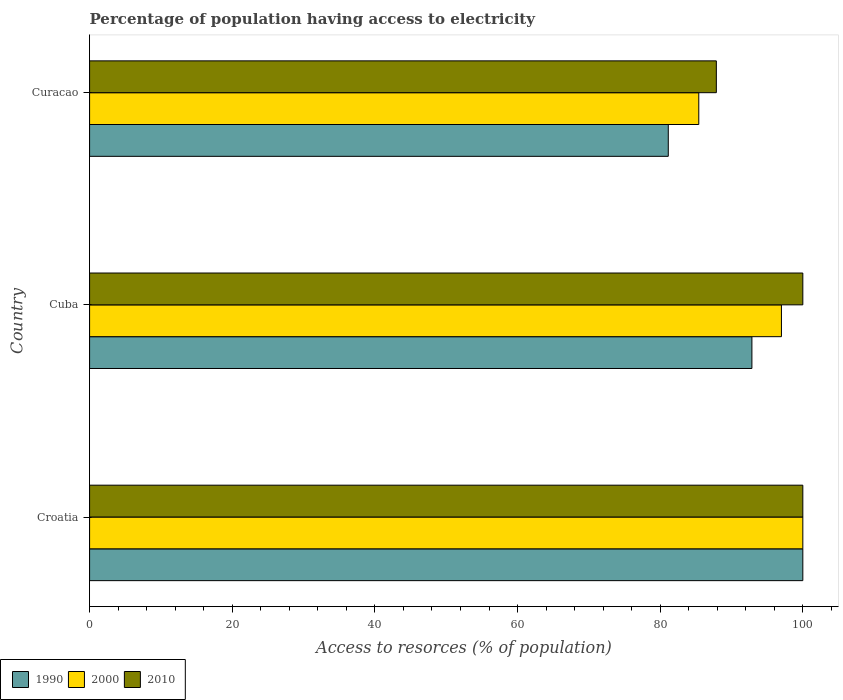How many different coloured bars are there?
Your answer should be compact. 3. How many groups of bars are there?
Provide a succinct answer. 3. Are the number of bars per tick equal to the number of legend labels?
Give a very brief answer. Yes. How many bars are there on the 1st tick from the top?
Your response must be concise. 3. How many bars are there on the 1st tick from the bottom?
Make the answer very short. 3. What is the label of the 2nd group of bars from the top?
Give a very brief answer. Cuba. In how many cases, is the number of bars for a given country not equal to the number of legend labels?
Provide a short and direct response. 0. What is the percentage of population having access to electricity in 1990 in Croatia?
Offer a terse response. 100. Across all countries, what is the maximum percentage of population having access to electricity in 2010?
Ensure brevity in your answer.  100. Across all countries, what is the minimum percentage of population having access to electricity in 2010?
Keep it short and to the point. 87.87. In which country was the percentage of population having access to electricity in 1990 maximum?
Offer a very short reply. Croatia. In which country was the percentage of population having access to electricity in 2000 minimum?
Your answer should be very brief. Curacao. What is the total percentage of population having access to electricity in 1990 in the graph?
Offer a terse response. 274. What is the difference between the percentage of population having access to electricity in 1990 in Cuba and that in Curacao?
Give a very brief answer. 11.73. What is the difference between the percentage of population having access to electricity in 1990 in Cuba and the percentage of population having access to electricity in 2010 in Curacao?
Your answer should be very brief. 4.99. What is the average percentage of population having access to electricity in 2000 per country?
Your answer should be compact. 94.14. What is the difference between the percentage of population having access to electricity in 2000 and percentage of population having access to electricity in 2010 in Curacao?
Your response must be concise. -2.46. What is the ratio of the percentage of population having access to electricity in 2010 in Cuba to that in Curacao?
Ensure brevity in your answer.  1.14. Is the percentage of population having access to electricity in 2010 in Croatia less than that in Cuba?
Your answer should be compact. No. What is the difference between the highest and the lowest percentage of population having access to electricity in 2000?
Your answer should be compact. 14.59. In how many countries, is the percentage of population having access to electricity in 1990 greater than the average percentage of population having access to electricity in 1990 taken over all countries?
Make the answer very short. 2. Is the sum of the percentage of population having access to electricity in 1990 in Croatia and Cuba greater than the maximum percentage of population having access to electricity in 2000 across all countries?
Give a very brief answer. Yes. What does the 1st bar from the top in Curacao represents?
Offer a very short reply. 2010. What does the 2nd bar from the bottom in Croatia represents?
Provide a short and direct response. 2000. Is it the case that in every country, the sum of the percentage of population having access to electricity in 1990 and percentage of population having access to electricity in 2010 is greater than the percentage of population having access to electricity in 2000?
Offer a terse response. Yes. Are all the bars in the graph horizontal?
Make the answer very short. Yes. Are the values on the major ticks of X-axis written in scientific E-notation?
Provide a short and direct response. No. Where does the legend appear in the graph?
Provide a succinct answer. Bottom left. How are the legend labels stacked?
Make the answer very short. Horizontal. What is the title of the graph?
Provide a succinct answer. Percentage of population having access to electricity. Does "1989" appear as one of the legend labels in the graph?
Offer a terse response. No. What is the label or title of the X-axis?
Provide a short and direct response. Access to resorces (% of population). What is the label or title of the Y-axis?
Make the answer very short. Country. What is the Access to resorces (% of population) in 1990 in Cuba?
Ensure brevity in your answer.  92.86. What is the Access to resorces (% of population) of 2000 in Cuba?
Provide a short and direct response. 97. What is the Access to resorces (% of population) of 1990 in Curacao?
Offer a very short reply. 81.14. What is the Access to resorces (% of population) in 2000 in Curacao?
Make the answer very short. 85.41. What is the Access to resorces (% of population) of 2010 in Curacao?
Your answer should be very brief. 87.87. Across all countries, what is the minimum Access to resorces (% of population) in 1990?
Keep it short and to the point. 81.14. Across all countries, what is the minimum Access to resorces (% of population) in 2000?
Offer a very short reply. 85.41. Across all countries, what is the minimum Access to resorces (% of population) of 2010?
Give a very brief answer. 87.87. What is the total Access to resorces (% of population) in 1990 in the graph?
Give a very brief answer. 274. What is the total Access to resorces (% of population) of 2000 in the graph?
Ensure brevity in your answer.  282.41. What is the total Access to resorces (% of population) in 2010 in the graph?
Your answer should be very brief. 287.87. What is the difference between the Access to resorces (% of population) of 1990 in Croatia and that in Cuba?
Ensure brevity in your answer.  7.14. What is the difference between the Access to resorces (% of population) in 2000 in Croatia and that in Cuba?
Keep it short and to the point. 3. What is the difference between the Access to resorces (% of population) in 1990 in Croatia and that in Curacao?
Your response must be concise. 18.86. What is the difference between the Access to resorces (% of population) of 2000 in Croatia and that in Curacao?
Give a very brief answer. 14.59. What is the difference between the Access to resorces (% of population) in 2010 in Croatia and that in Curacao?
Provide a short and direct response. 12.13. What is the difference between the Access to resorces (% of population) in 1990 in Cuba and that in Curacao?
Ensure brevity in your answer.  11.73. What is the difference between the Access to resorces (% of population) in 2000 in Cuba and that in Curacao?
Give a very brief answer. 11.59. What is the difference between the Access to resorces (% of population) in 2010 in Cuba and that in Curacao?
Provide a succinct answer. 12.13. What is the difference between the Access to resorces (% of population) in 1990 in Croatia and the Access to resorces (% of population) in 2000 in Curacao?
Ensure brevity in your answer.  14.59. What is the difference between the Access to resorces (% of population) in 1990 in Croatia and the Access to resorces (% of population) in 2010 in Curacao?
Your response must be concise. 12.13. What is the difference between the Access to resorces (% of population) of 2000 in Croatia and the Access to resorces (% of population) of 2010 in Curacao?
Make the answer very short. 12.13. What is the difference between the Access to resorces (% of population) of 1990 in Cuba and the Access to resorces (% of population) of 2000 in Curacao?
Your answer should be very brief. 7.45. What is the difference between the Access to resorces (% of population) of 1990 in Cuba and the Access to resorces (% of population) of 2010 in Curacao?
Your response must be concise. 4.99. What is the difference between the Access to resorces (% of population) in 2000 in Cuba and the Access to resorces (% of population) in 2010 in Curacao?
Offer a terse response. 9.13. What is the average Access to resorces (% of population) in 1990 per country?
Offer a terse response. 91.33. What is the average Access to resorces (% of population) of 2000 per country?
Give a very brief answer. 94.14. What is the average Access to resorces (% of population) in 2010 per country?
Your answer should be compact. 95.96. What is the difference between the Access to resorces (% of population) of 1990 and Access to resorces (% of population) of 2000 in Croatia?
Your answer should be compact. 0. What is the difference between the Access to resorces (% of population) in 1990 and Access to resorces (% of population) in 2000 in Cuba?
Your response must be concise. -4.14. What is the difference between the Access to resorces (% of population) in 1990 and Access to resorces (% of population) in 2010 in Cuba?
Give a very brief answer. -7.14. What is the difference between the Access to resorces (% of population) in 1990 and Access to resorces (% of population) in 2000 in Curacao?
Make the answer very short. -4.28. What is the difference between the Access to resorces (% of population) of 1990 and Access to resorces (% of population) of 2010 in Curacao?
Make the answer very short. -6.74. What is the difference between the Access to resorces (% of population) of 2000 and Access to resorces (% of population) of 2010 in Curacao?
Give a very brief answer. -2.46. What is the ratio of the Access to resorces (% of population) in 1990 in Croatia to that in Cuba?
Your answer should be compact. 1.08. What is the ratio of the Access to resorces (% of population) of 2000 in Croatia to that in Cuba?
Your response must be concise. 1.03. What is the ratio of the Access to resorces (% of population) in 1990 in Croatia to that in Curacao?
Your answer should be very brief. 1.23. What is the ratio of the Access to resorces (% of population) in 2000 in Croatia to that in Curacao?
Offer a very short reply. 1.17. What is the ratio of the Access to resorces (% of population) of 2010 in Croatia to that in Curacao?
Offer a very short reply. 1.14. What is the ratio of the Access to resorces (% of population) in 1990 in Cuba to that in Curacao?
Provide a short and direct response. 1.14. What is the ratio of the Access to resorces (% of population) in 2000 in Cuba to that in Curacao?
Make the answer very short. 1.14. What is the ratio of the Access to resorces (% of population) of 2010 in Cuba to that in Curacao?
Provide a succinct answer. 1.14. What is the difference between the highest and the second highest Access to resorces (% of population) in 1990?
Provide a succinct answer. 7.14. What is the difference between the highest and the second highest Access to resorces (% of population) of 2000?
Provide a short and direct response. 3. What is the difference between the highest and the lowest Access to resorces (% of population) in 1990?
Provide a short and direct response. 18.86. What is the difference between the highest and the lowest Access to resorces (% of population) of 2000?
Offer a terse response. 14.59. What is the difference between the highest and the lowest Access to resorces (% of population) in 2010?
Provide a short and direct response. 12.13. 